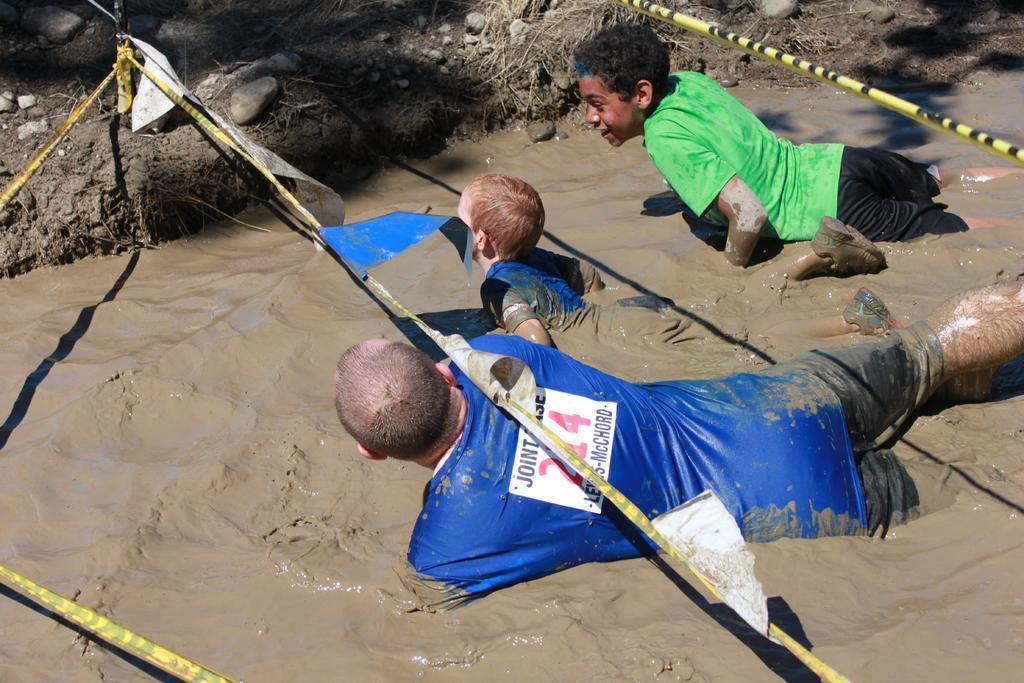How would you summarize this image in a sentence or two? In this image we can see people in the sludge. In the background there are stones, plants and ropes. 